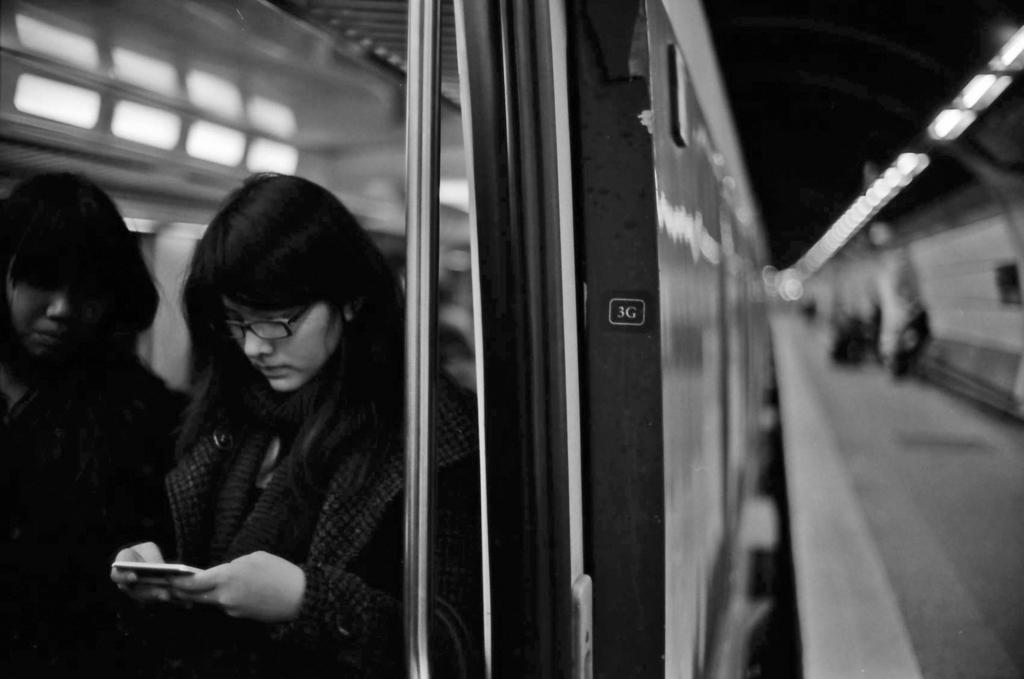What can be seen on the left side of the image? There are persons standing on the left side of the image. What is the woman in the center of the image doing? The woman is standing in the center of the image and holding a mobile phone in her hand. Can you describe the quality of the image on the left side? The left side of the image is blurry. What type of plants can be seen growing in the drawer in the image? There is no drawer or plants present in the image. Is the woman playing a guitar in the image? There is no guitar present in the image; the woman is holding a mobile phone. 